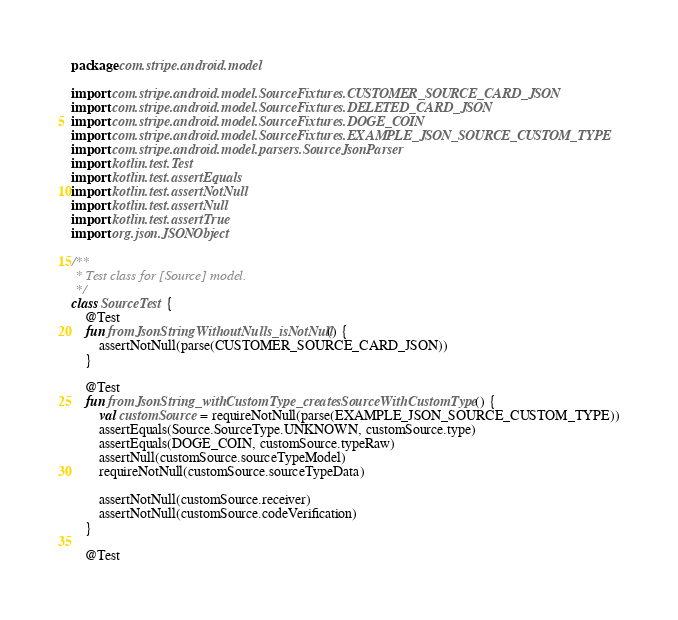Convert code to text. <code><loc_0><loc_0><loc_500><loc_500><_Kotlin_>package com.stripe.android.model

import com.stripe.android.model.SourceFixtures.CUSTOMER_SOURCE_CARD_JSON
import com.stripe.android.model.SourceFixtures.DELETED_CARD_JSON
import com.stripe.android.model.SourceFixtures.DOGE_COIN
import com.stripe.android.model.SourceFixtures.EXAMPLE_JSON_SOURCE_CUSTOM_TYPE
import com.stripe.android.model.parsers.SourceJsonParser
import kotlin.test.Test
import kotlin.test.assertEquals
import kotlin.test.assertNotNull
import kotlin.test.assertNull
import kotlin.test.assertTrue
import org.json.JSONObject

/**
 * Test class for [Source] model.
 */
class SourceTest {
    @Test
    fun fromJsonStringWithoutNulls_isNotNull() {
        assertNotNull(parse(CUSTOMER_SOURCE_CARD_JSON))
    }

    @Test
    fun fromJsonString_withCustomType_createsSourceWithCustomType() {
        val customSource = requireNotNull(parse(EXAMPLE_JSON_SOURCE_CUSTOM_TYPE))
        assertEquals(Source.SourceType.UNKNOWN, customSource.type)
        assertEquals(DOGE_COIN, customSource.typeRaw)
        assertNull(customSource.sourceTypeModel)
        requireNotNull(customSource.sourceTypeData)

        assertNotNull(customSource.receiver)
        assertNotNull(customSource.codeVerification)
    }

    @Test</code> 